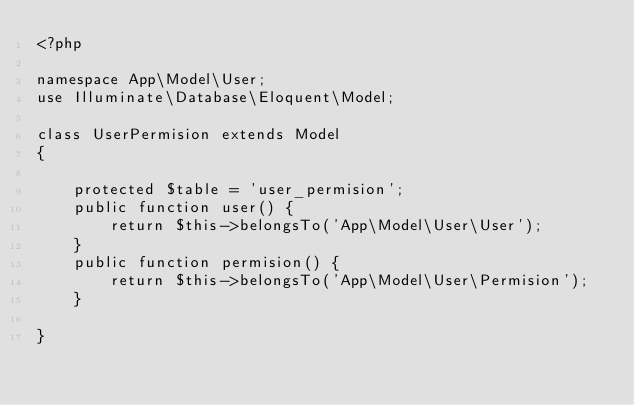<code> <loc_0><loc_0><loc_500><loc_500><_PHP_><?php

namespace App\Model\User;
use Illuminate\Database\Eloquent\Model;

class UserPermision extends Model
{
   
    protected $table = 'user_permision';
    public function user() {
        return $this->belongsTo('App\Model\User\User');
    }
    public function permision() {
        return $this->belongsTo('App\Model\User\Permision');
    }
   
}
</code> 